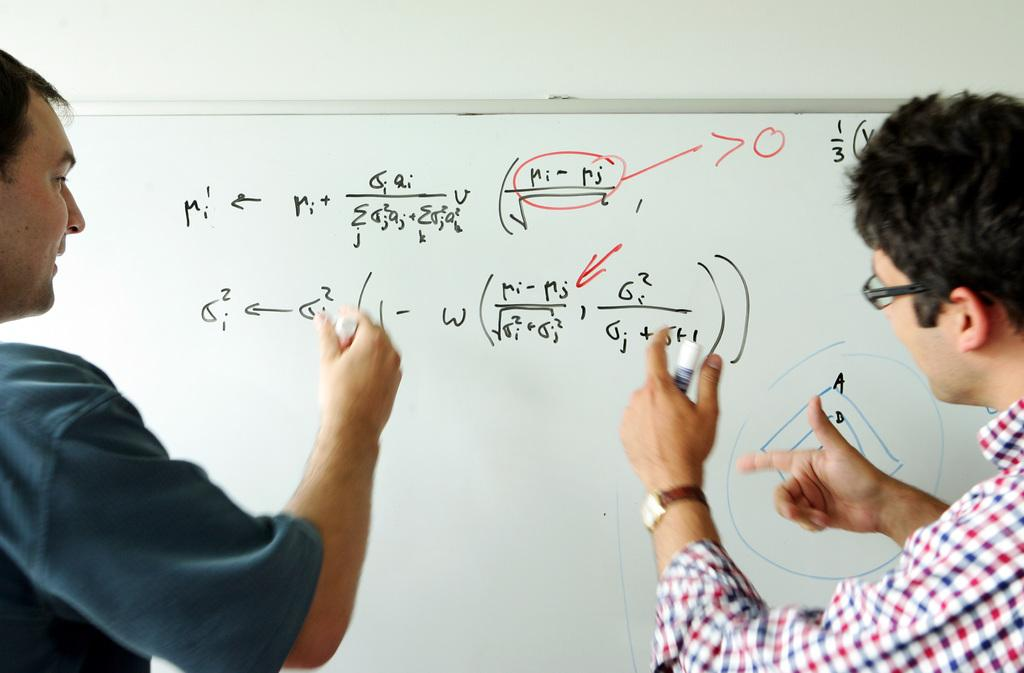<image>
Offer a succinct explanation of the picture presented. Men are solving complicated Algebra problems on a white board. 